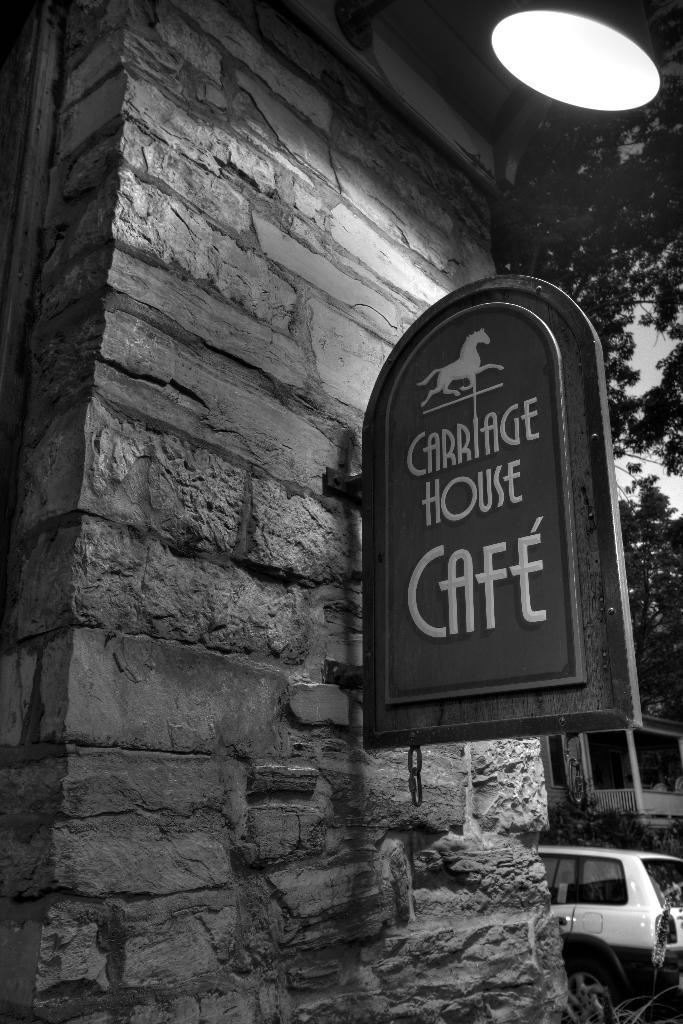What type of structure can be seen in the image? There is a wall in the image. What is attached to the wall? There is a board with text in the image, and an image on the board. What else is present in the image? There is a vehicle, trees, a plant, and the sky is visible in the image. How many pigs are visible in the image? There are no pigs present in the image. What type of stem is supporting the plant in the image? The plant in the image does not have a visible stem, and the type of stem cannot be determined from the image. 